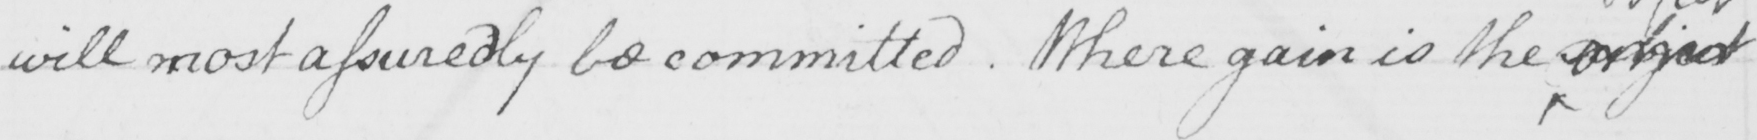What does this handwritten line say? will most assuredly be committed . Where gain is the subject 